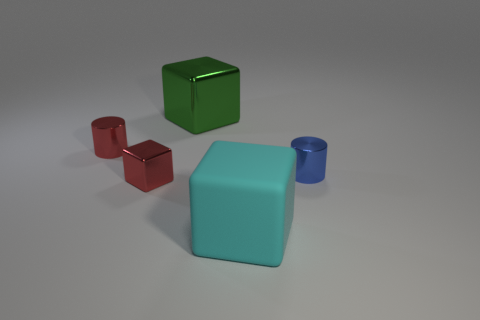There is a big thing that is behind the small cube; what shape is it?
Your response must be concise. Cube. What number of tiny blocks have the same color as the rubber object?
Provide a succinct answer. 0. What is the color of the matte cube?
Your answer should be very brief. Cyan. How many objects are on the left side of the metallic cylinder behind the small blue metal object?
Ensure brevity in your answer.  0. Do the cyan matte block and the cylinder that is behind the blue shiny thing have the same size?
Your response must be concise. No. Does the blue thing have the same size as the cyan rubber block?
Give a very brief answer. No. Are there any brown cylinders that have the same size as the blue cylinder?
Offer a very short reply. No. There is a small cylinder behind the tiny blue thing; what material is it?
Offer a terse response. Metal. What color is the block that is the same material as the large green thing?
Ensure brevity in your answer.  Red. What number of rubber things are either large brown cylinders or cylinders?
Offer a terse response. 0. 